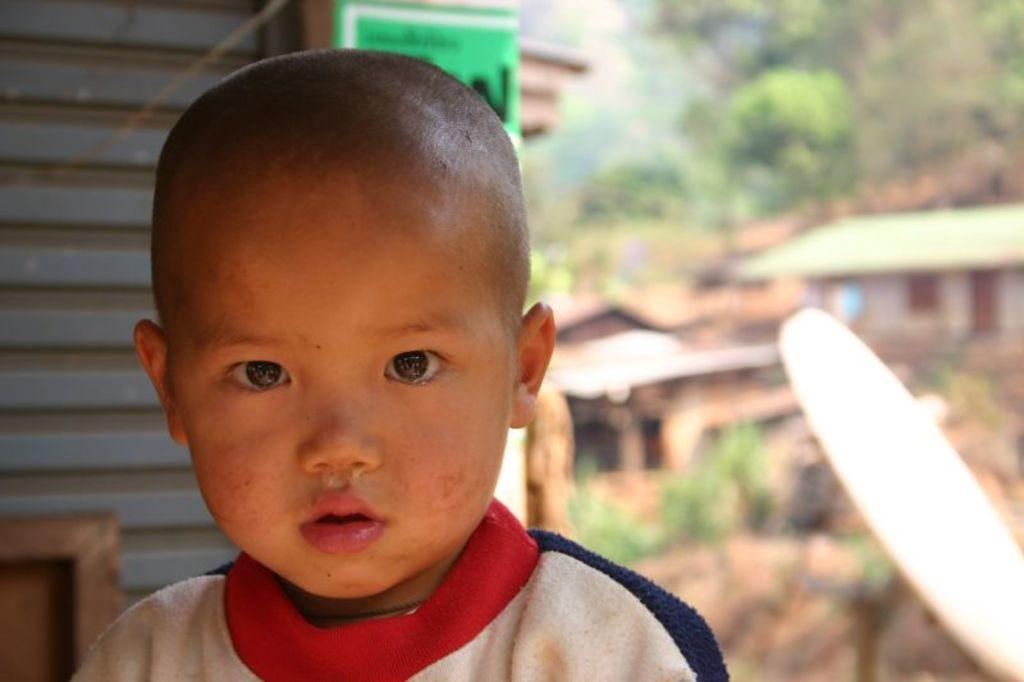Who is the main subject in the front of the image? There is a boy in the front of the image. What can be seen in the background of the image? There are trees, buildings, and plants in the background of the image. What color is the kitty that is sitting on the boy's lap in the image? There is no kitty present in the image; the boy is the main subject in the front of the image. 